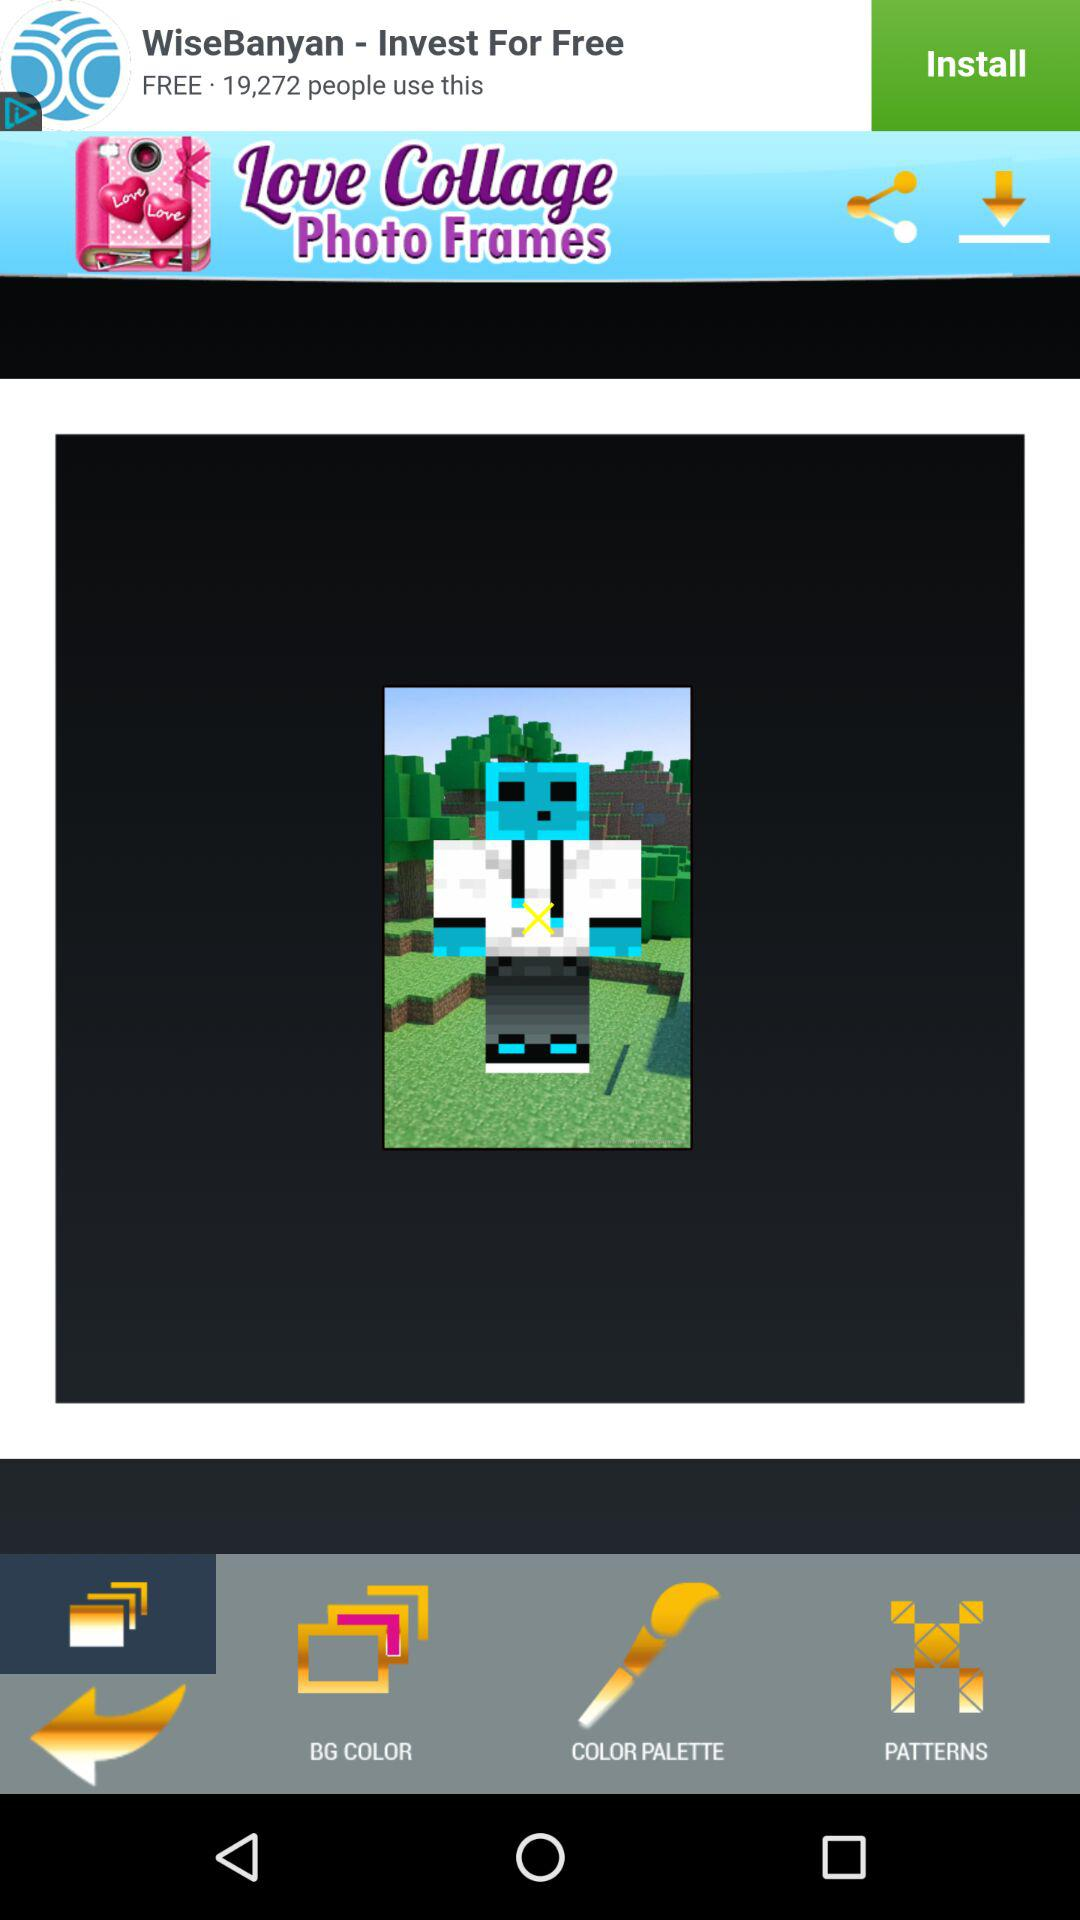What is the name of the application? The name of the application is "Love Collage Photo Frames". 